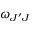<formula> <loc_0><loc_0><loc_500><loc_500>\omega _ { J ^ { \prime } J }</formula> 